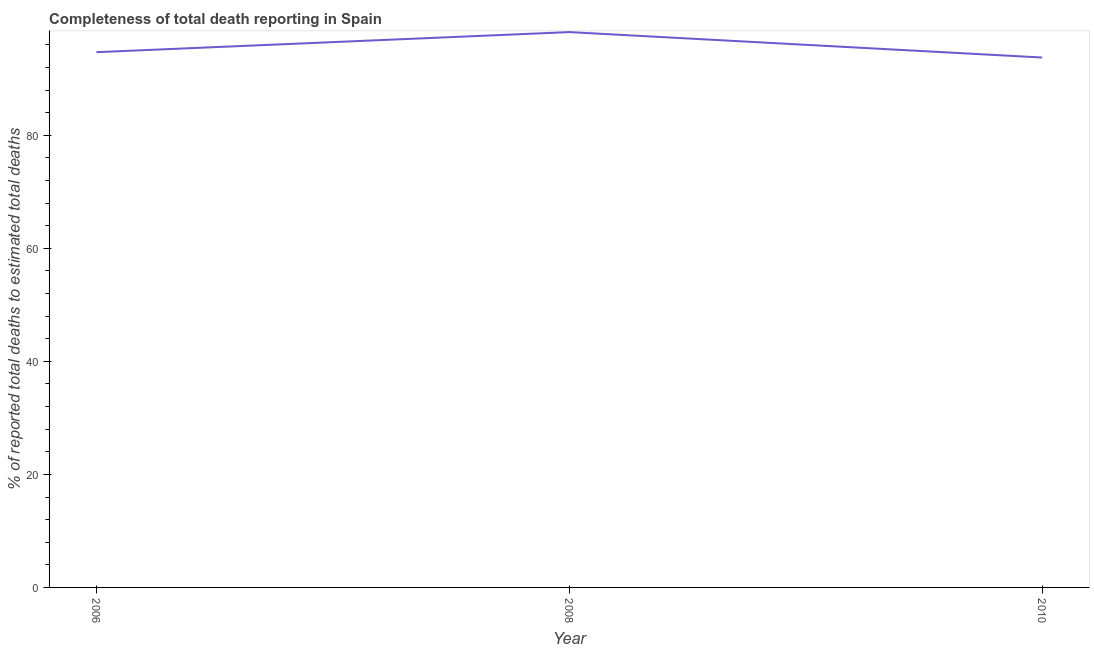What is the completeness of total death reports in 2006?
Your answer should be compact. 94.73. Across all years, what is the maximum completeness of total death reports?
Make the answer very short. 98.27. Across all years, what is the minimum completeness of total death reports?
Offer a very short reply. 93.77. What is the sum of the completeness of total death reports?
Ensure brevity in your answer.  286.77. What is the difference between the completeness of total death reports in 2008 and 2010?
Give a very brief answer. 4.5. What is the average completeness of total death reports per year?
Give a very brief answer. 95.59. What is the median completeness of total death reports?
Ensure brevity in your answer.  94.73. In how many years, is the completeness of total death reports greater than 12 %?
Your answer should be very brief. 3. Do a majority of the years between 2010 and 2008 (inclusive) have completeness of total death reports greater than 4 %?
Ensure brevity in your answer.  No. What is the ratio of the completeness of total death reports in 2006 to that in 2010?
Your response must be concise. 1.01. Is the completeness of total death reports in 2008 less than that in 2010?
Your answer should be compact. No. What is the difference between the highest and the second highest completeness of total death reports?
Offer a very short reply. 3.55. Is the sum of the completeness of total death reports in 2006 and 2008 greater than the maximum completeness of total death reports across all years?
Make the answer very short. Yes. What is the difference between the highest and the lowest completeness of total death reports?
Make the answer very short. 4.5. How many years are there in the graph?
Keep it short and to the point. 3. Are the values on the major ticks of Y-axis written in scientific E-notation?
Provide a short and direct response. No. Does the graph contain grids?
Offer a very short reply. No. What is the title of the graph?
Your answer should be compact. Completeness of total death reporting in Spain. What is the label or title of the X-axis?
Provide a short and direct response. Year. What is the label or title of the Y-axis?
Offer a terse response. % of reported total deaths to estimated total deaths. What is the % of reported total deaths to estimated total deaths of 2006?
Make the answer very short. 94.73. What is the % of reported total deaths to estimated total deaths in 2008?
Provide a short and direct response. 98.27. What is the % of reported total deaths to estimated total deaths of 2010?
Offer a terse response. 93.77. What is the difference between the % of reported total deaths to estimated total deaths in 2006 and 2008?
Your answer should be very brief. -3.55. What is the difference between the % of reported total deaths to estimated total deaths in 2006 and 2010?
Your response must be concise. 0.95. What is the difference between the % of reported total deaths to estimated total deaths in 2008 and 2010?
Your response must be concise. 4.5. What is the ratio of the % of reported total deaths to estimated total deaths in 2008 to that in 2010?
Keep it short and to the point. 1.05. 